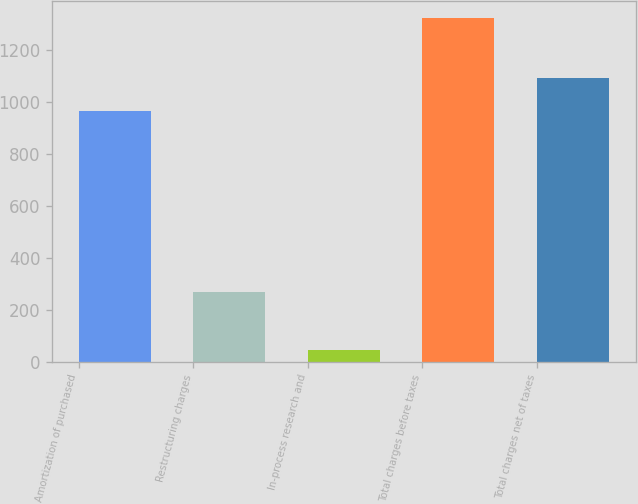Convert chart to OTSL. <chart><loc_0><loc_0><loc_500><loc_500><bar_chart><fcel>Amortization of purchased<fcel>Restructuring charges<fcel>In-process research and<fcel>Total charges before taxes<fcel>Total charges net of taxes<nl><fcel>967<fcel>270<fcel>45<fcel>1323<fcel>1094.8<nl></chart> 